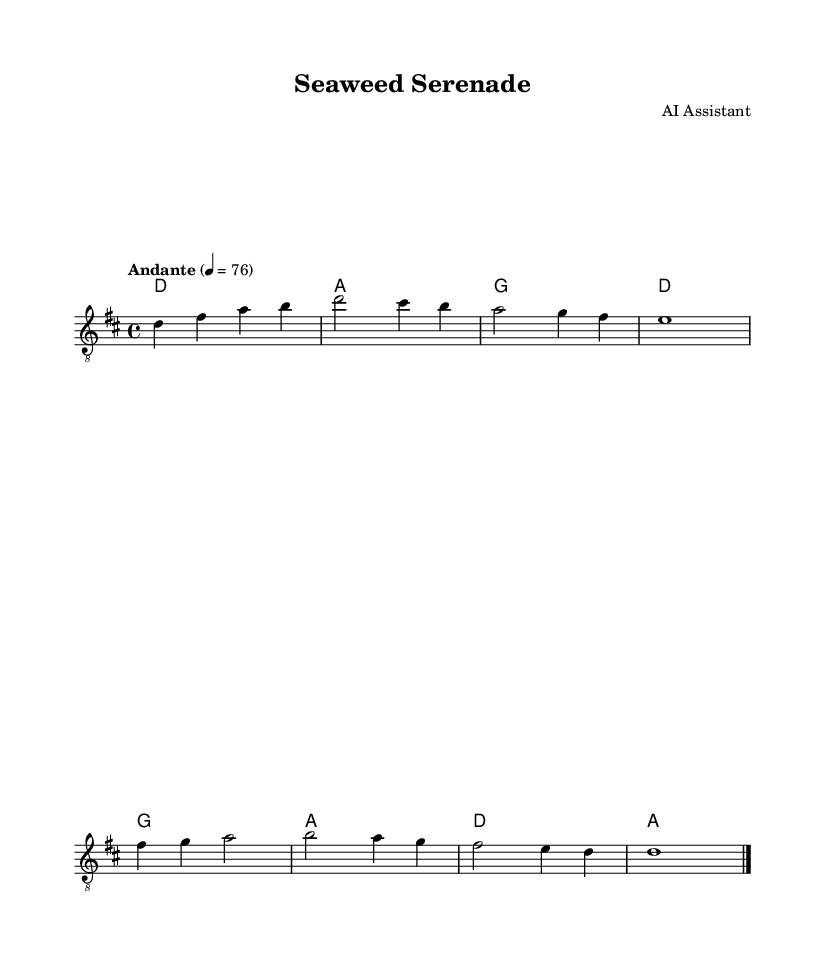What is the key signature of this music? The key signature indicated at the beginning of the staff shows that there are two sharps, which corresponds to the key of D major.
Answer: D major What is the time signature of this piece? The time signature shown at the beginning is 4/4, meaning there are four beats in a measure and a quarter note receives one beat.
Answer: 4/4 What is the tempo marking? The tempo marking indicates "Andante," which suggests a moderate walking pace, typically around 76 beats per minute.
Answer: Andante How many measures are in the piece? By counting the measures visually from the start of the score to the end, there are a total of 8 measures.
Answer: 8 What is the first chord played? The first chord listed in the chord names section is D, which is also the first chord in the progression at the beginning of the piece.
Answer: D Which note is held for the longest duration? The note E is held as a whole note (e1), indicating it is sustained for four beats, longer than any other note in this piece.
Answer: E How is this piece structured in terms of chord progression? The chord progression follows a pattern that moves from D to A, then to G, and back to D, showing a cyclical structure common in relaxing melodies.
Answer: D - A - G - D 